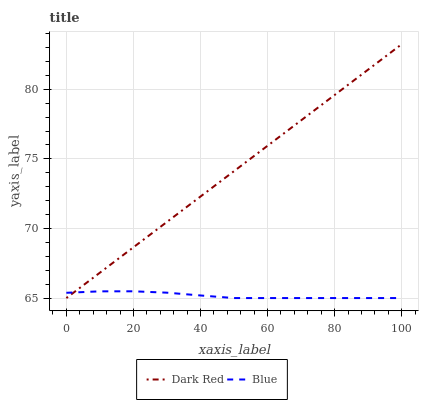Does Blue have the minimum area under the curve?
Answer yes or no. Yes. Does Dark Red have the maximum area under the curve?
Answer yes or no. Yes. Does Dark Red have the minimum area under the curve?
Answer yes or no. No. Is Dark Red the smoothest?
Answer yes or no. Yes. Is Blue the roughest?
Answer yes or no. Yes. Is Dark Red the roughest?
Answer yes or no. No. Does Blue have the lowest value?
Answer yes or no. Yes. Does Dark Red have the highest value?
Answer yes or no. Yes. Does Dark Red intersect Blue?
Answer yes or no. Yes. Is Dark Red less than Blue?
Answer yes or no. No. Is Dark Red greater than Blue?
Answer yes or no. No. 